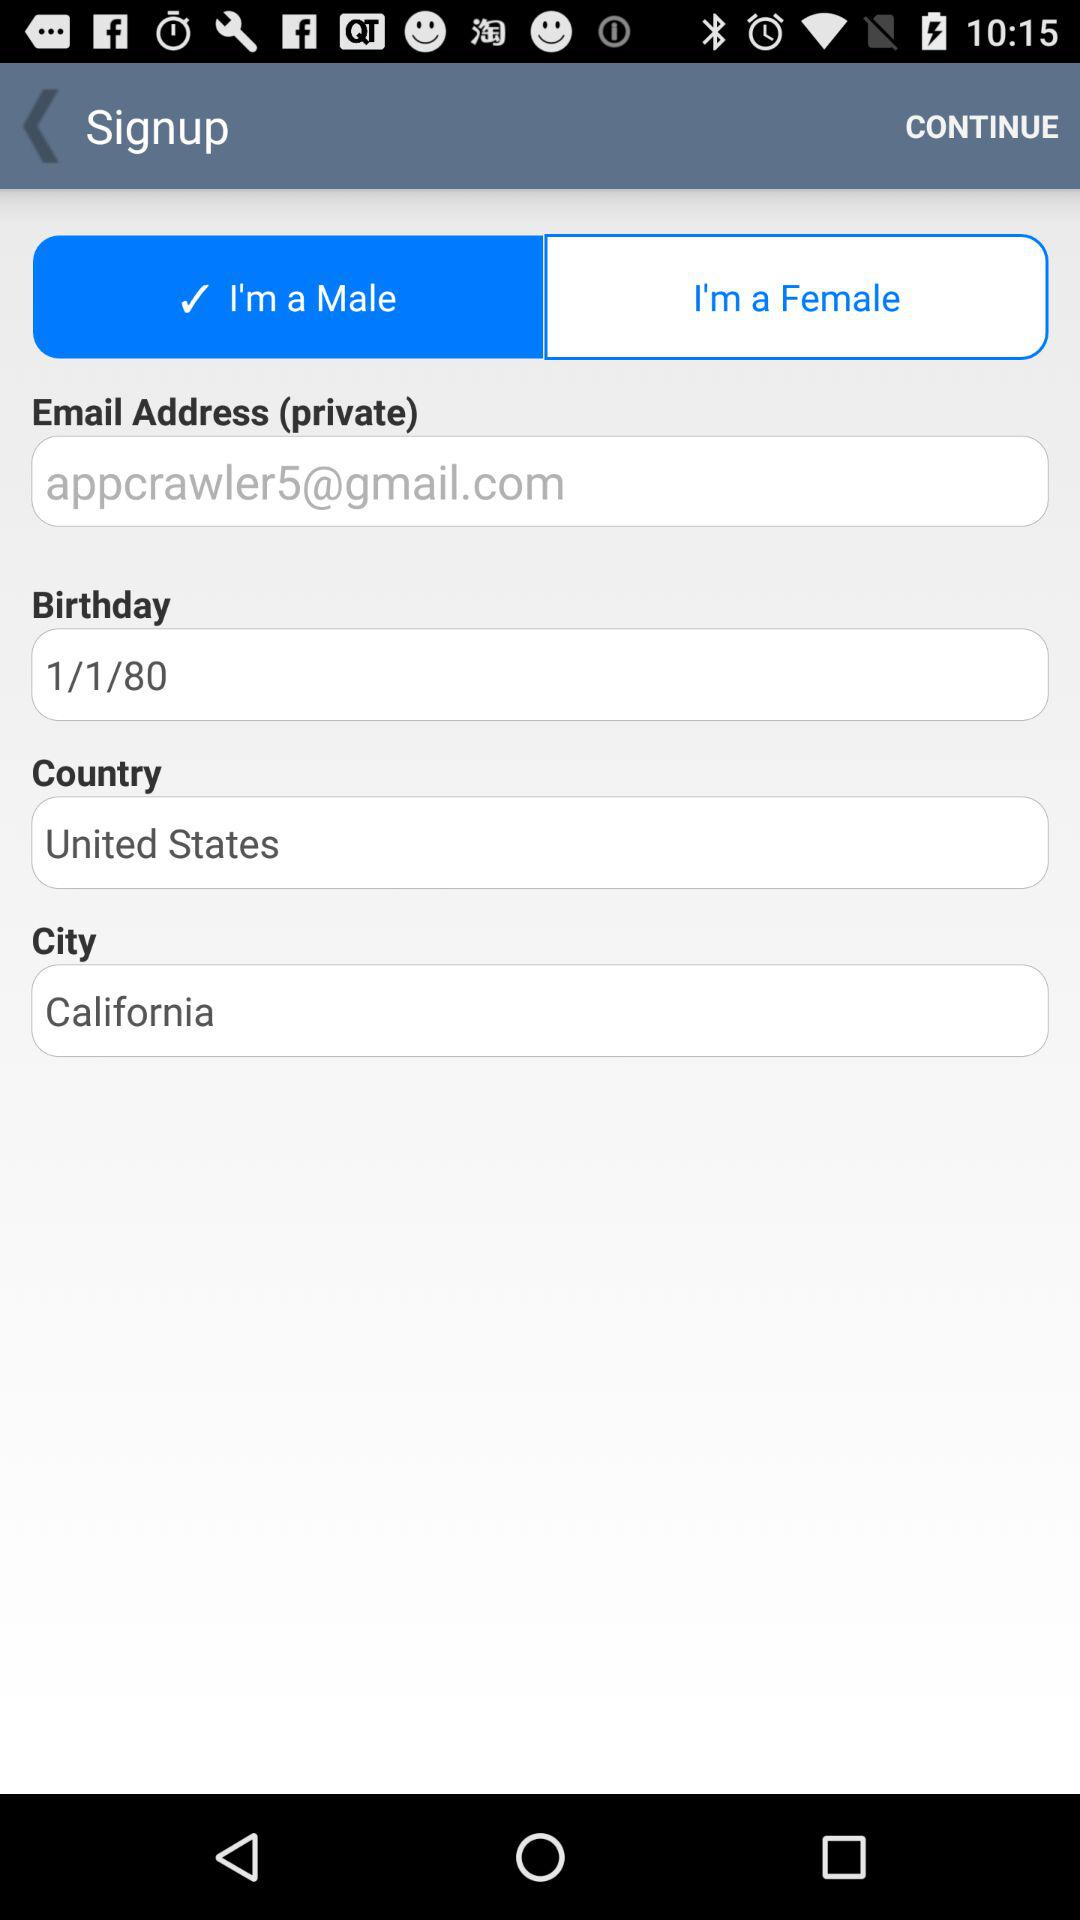Which city is the user from? The user is from California. 